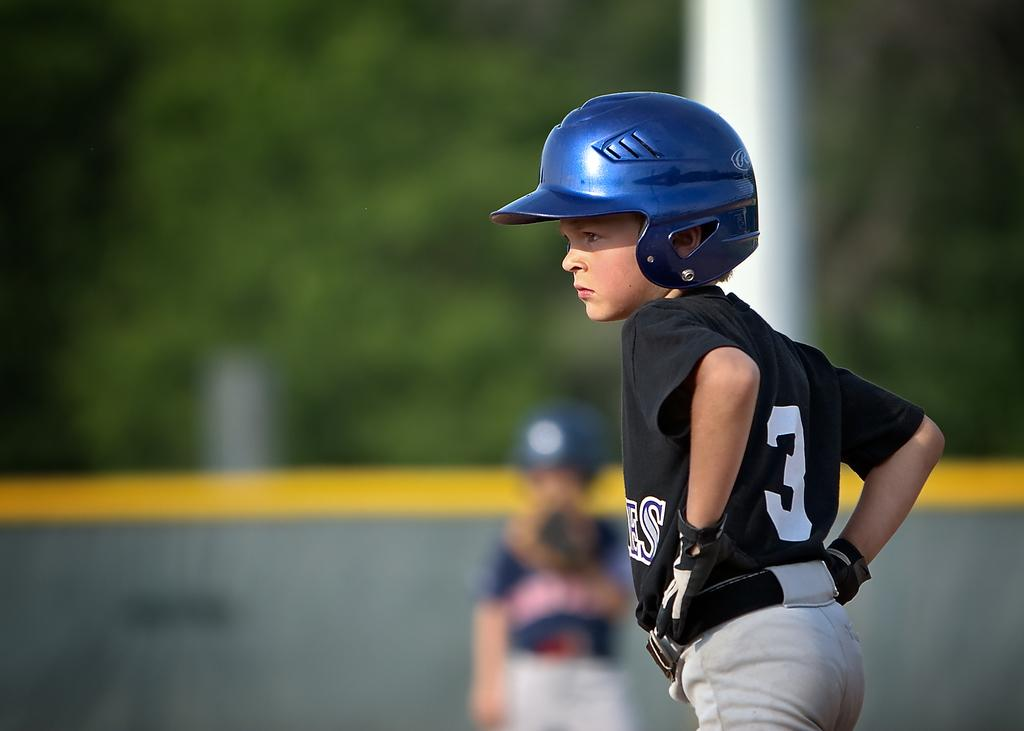Who is present in the image? There are children in the image. What are the children wearing on their heads? The children are wearing helmets. Where are the children standing? The children are standing on the ground. What can be seen in the background of the image? There are trees in the background of the image. How many feathers can be seen falling from the tree in the image? There are no feathers or trees present in the image; it features children wearing helmets and standing on the ground. 